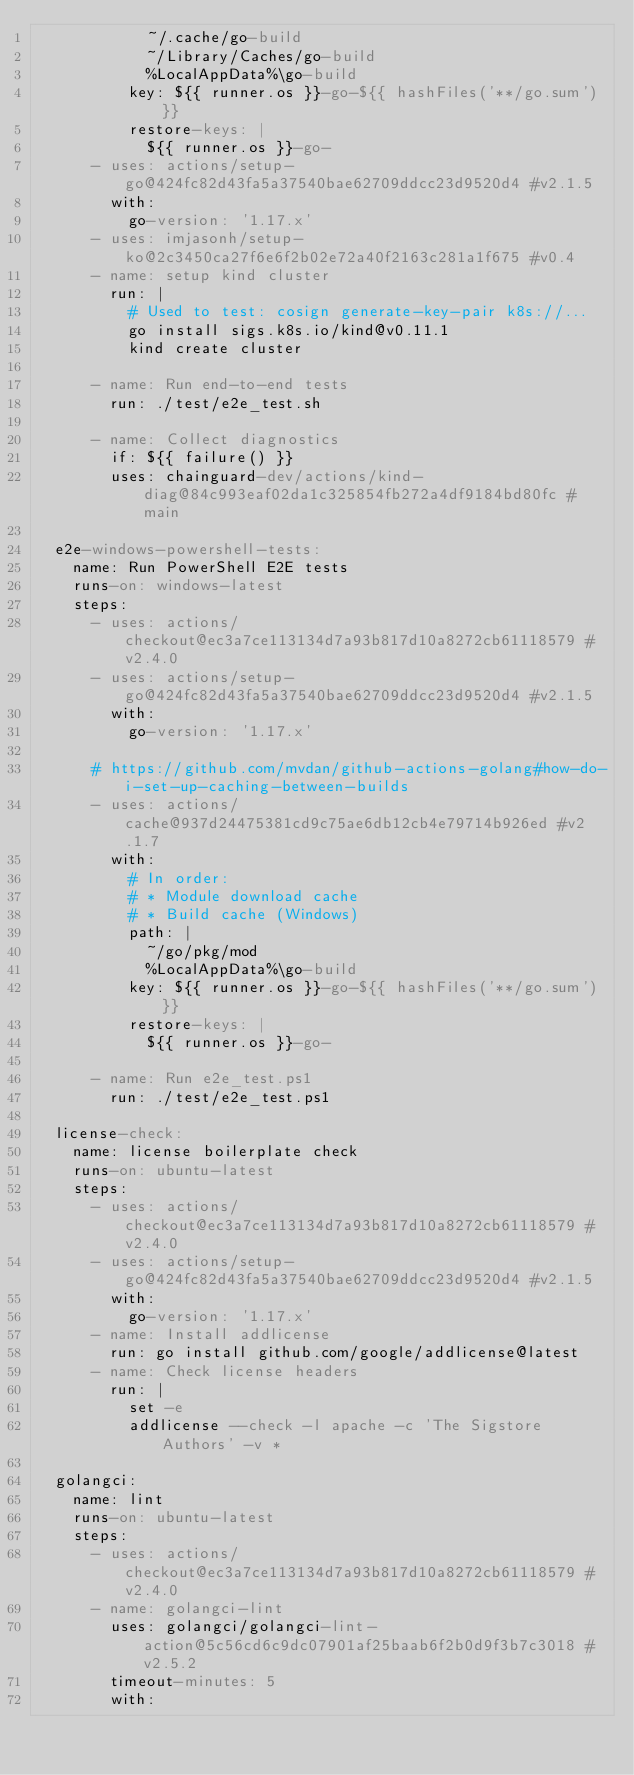Convert code to text. <code><loc_0><loc_0><loc_500><loc_500><_YAML_>            ~/.cache/go-build
            ~/Library/Caches/go-build
            %LocalAppData%\go-build
          key: ${{ runner.os }}-go-${{ hashFiles('**/go.sum') }}
          restore-keys: |
            ${{ runner.os }}-go-
      - uses: actions/setup-go@424fc82d43fa5a37540bae62709ddcc23d9520d4 #v2.1.5
        with:
          go-version: '1.17.x'
      - uses: imjasonh/setup-ko@2c3450ca27f6e6f2b02e72a40f2163c281a1f675 #v0.4
      - name: setup kind cluster
        run: |
          # Used to test: cosign generate-key-pair k8s://...
          go install sigs.k8s.io/kind@v0.11.1
          kind create cluster

      - name: Run end-to-end tests
        run: ./test/e2e_test.sh

      - name: Collect diagnostics
        if: ${{ failure() }}
        uses: chainguard-dev/actions/kind-diag@84c993eaf02da1c325854fb272a4df9184bd80fc # main

  e2e-windows-powershell-tests:
    name: Run PowerShell E2E tests
    runs-on: windows-latest
    steps:
      - uses: actions/checkout@ec3a7ce113134d7a93b817d10a8272cb61118579 #v2.4.0
      - uses: actions/setup-go@424fc82d43fa5a37540bae62709ddcc23d9520d4 #v2.1.5
        with:
          go-version: '1.17.x'

      # https://github.com/mvdan/github-actions-golang#how-do-i-set-up-caching-between-builds
      - uses: actions/cache@937d24475381cd9c75ae6db12cb4e79714b926ed #v2.1.7
        with:
          # In order:
          # * Module download cache
          # * Build cache (Windows)
          path: |
            ~/go/pkg/mod
            %LocalAppData%\go-build
          key: ${{ runner.os }}-go-${{ hashFiles('**/go.sum') }}
          restore-keys: |
            ${{ runner.os }}-go-

      - name: Run e2e_test.ps1
        run: ./test/e2e_test.ps1

  license-check:
    name: license boilerplate check
    runs-on: ubuntu-latest
    steps:
      - uses: actions/checkout@ec3a7ce113134d7a93b817d10a8272cb61118579 #v2.4.0
      - uses: actions/setup-go@424fc82d43fa5a37540bae62709ddcc23d9520d4 #v2.1.5
        with:
          go-version: '1.17.x'
      - name: Install addlicense
        run: go install github.com/google/addlicense@latest
      - name: Check license headers
        run: |
          set -e
          addlicense --check -l apache -c 'The Sigstore Authors' -v *

  golangci:
    name: lint
    runs-on: ubuntu-latest
    steps:
      - uses: actions/checkout@ec3a7ce113134d7a93b817d10a8272cb61118579 #v2.4.0
      - name: golangci-lint
        uses: golangci/golangci-lint-action@5c56cd6c9dc07901af25baab6f2b0d9f3b7c3018 #v2.5.2
        timeout-minutes: 5
        with:</code> 